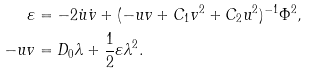Convert formula to latex. <formula><loc_0><loc_0><loc_500><loc_500>\varepsilon & = - 2 { \dot { u } } { \dot { v } } + ( - u v + C _ { 1 } v ^ { 2 } + C _ { 2 } u ^ { 2 } ) ^ { - 1 } \Phi ^ { 2 } , \\ - u v & = D _ { 0 } \lambda + \frac { 1 } { 2 } \varepsilon \lambda ^ { 2 } .</formula> 